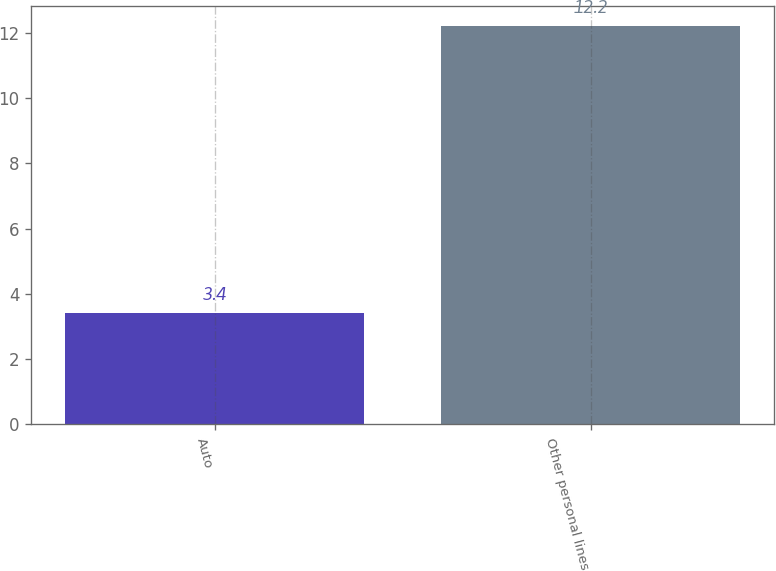Convert chart to OTSL. <chart><loc_0><loc_0><loc_500><loc_500><bar_chart><fcel>Auto<fcel>Other personal lines<nl><fcel>3.4<fcel>12.2<nl></chart> 